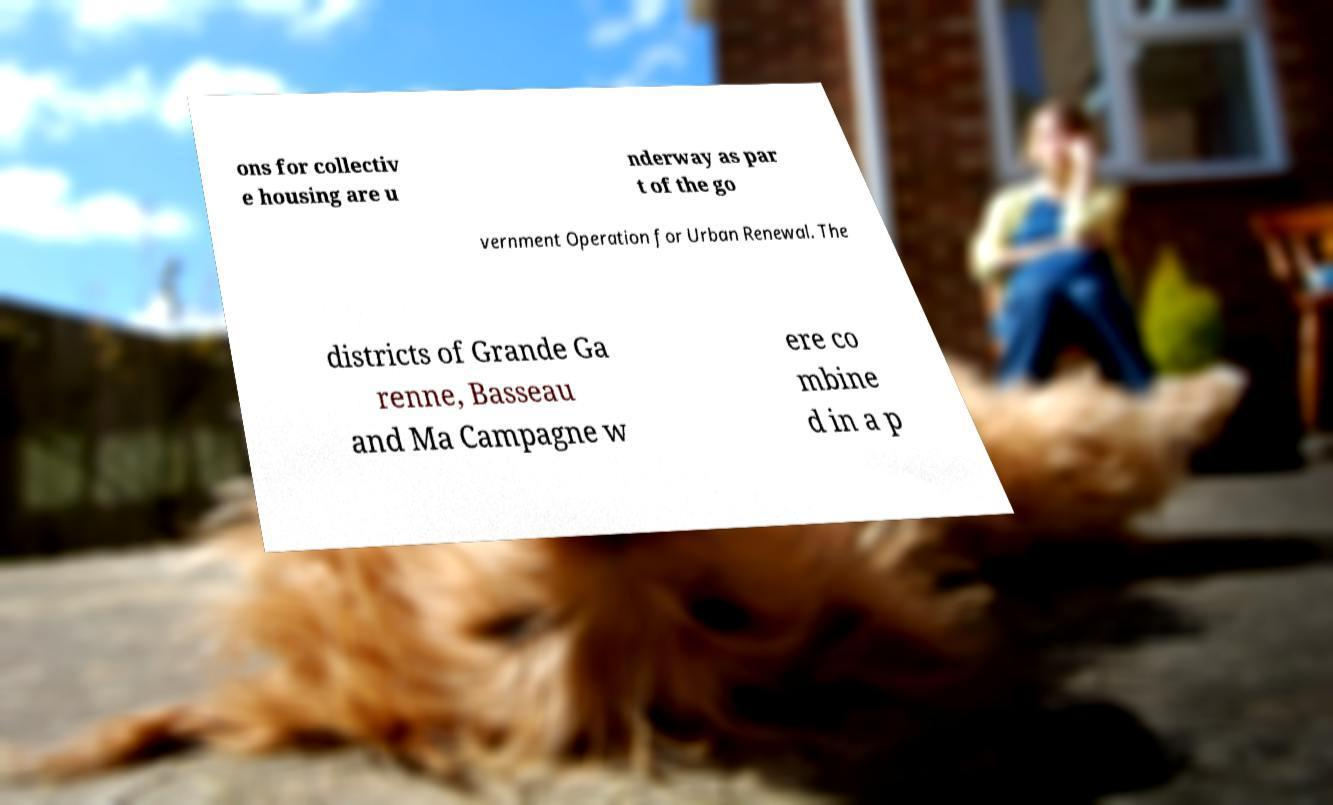Could you extract and type out the text from this image? ons for collectiv e housing are u nderway as par t of the go vernment Operation for Urban Renewal. The districts of Grande Ga renne, Basseau and Ma Campagne w ere co mbine d in a p 